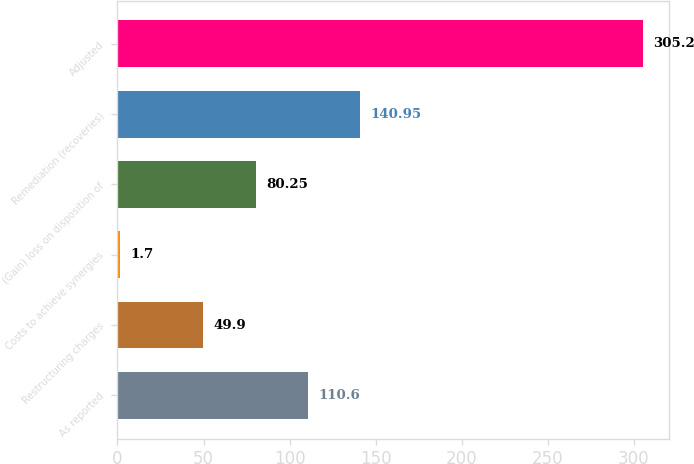Convert chart to OTSL. <chart><loc_0><loc_0><loc_500><loc_500><bar_chart><fcel>As reported<fcel>Restructuring charges<fcel>Costs to achieve synergies<fcel>(Gain) loss on disposition of<fcel>Remediation (recoveries)<fcel>Adjusted<nl><fcel>110.6<fcel>49.9<fcel>1.7<fcel>80.25<fcel>140.95<fcel>305.2<nl></chart> 